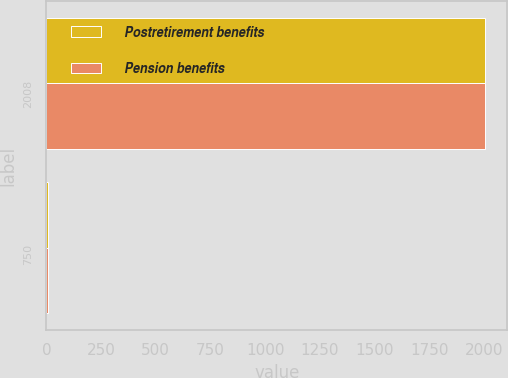Convert chart. <chart><loc_0><loc_0><loc_500><loc_500><stacked_bar_chart><ecel><fcel>2008<fcel>750<nl><fcel>Postretirement benefits<fcel>2007<fcel>6.5<nl><fcel>Pension benefits<fcel>2008<fcel>7.75<nl></chart> 